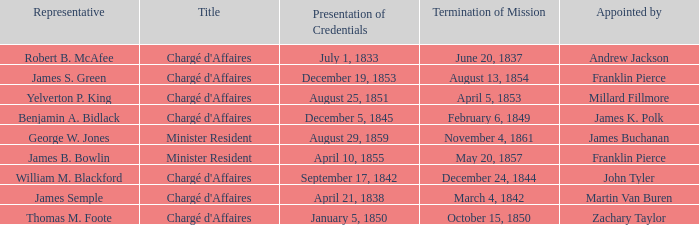What Representative has a Presentation of Credentails of April 10, 1855? James B. Bowlin. 